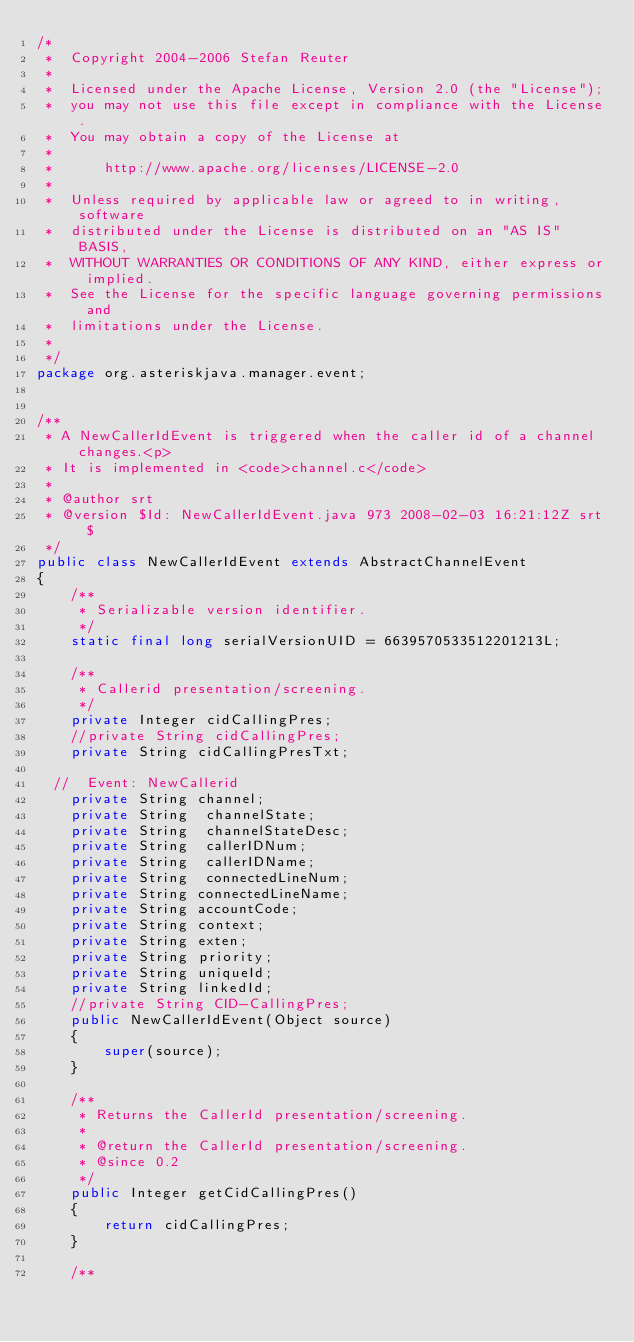Convert code to text. <code><loc_0><loc_0><loc_500><loc_500><_Java_>/*
 *  Copyright 2004-2006 Stefan Reuter
 *
 *  Licensed under the Apache License, Version 2.0 (the "License");
 *  you may not use this file except in compliance with the License.
 *  You may obtain a copy of the License at
 *
 *      http://www.apache.org/licenses/LICENSE-2.0
 *
 *  Unless required by applicable law or agreed to in writing, software
 *  distributed under the License is distributed on an "AS IS" BASIS,
 *  WITHOUT WARRANTIES OR CONDITIONS OF ANY KIND, either express or implied.
 *  See the License for the specific language governing permissions and
 *  limitations under the License.
 *
 */
package org.asteriskjava.manager.event;


/**
 * A NewCallerIdEvent is triggered when the caller id of a channel changes.<p>
 * It is implemented in <code>channel.c</code>
 * 
 * @author srt
 * @version $Id: NewCallerIdEvent.java 973 2008-02-03 16:21:12Z srt $
 */
public class NewCallerIdEvent extends AbstractChannelEvent
{
    /**
     * Serializable version identifier.
     */
    static final long serialVersionUID = 6639570533512201213L;

    /**
     * Callerid presentation/screening.
     */
    private Integer cidCallingPres;
    //private String cidCallingPres;
    private String cidCallingPresTxt;
    
  //  Event: NewCallerid
    private String channel;
    private String  channelState;
    private String  channelStateDesc;
    private String  callerIDNum;
    private String  callerIDName;
    private String  connectedLineNum;
    private String connectedLineName;
    private String accountCode;
    private String context;
    private String exten;
    private String priority;
    private String uniqueId;
    private String linkedId;
    //private String CID-CallingPres;
    public NewCallerIdEvent(Object source)
    {
        super(source);
    }

    /**
     * Returns the CallerId presentation/screening.
     * 
     * @return the CallerId presentation/screening.
     * @since 0.2
     */
    public Integer getCidCallingPres()
    {
        return cidCallingPres;
    }

    /**</code> 